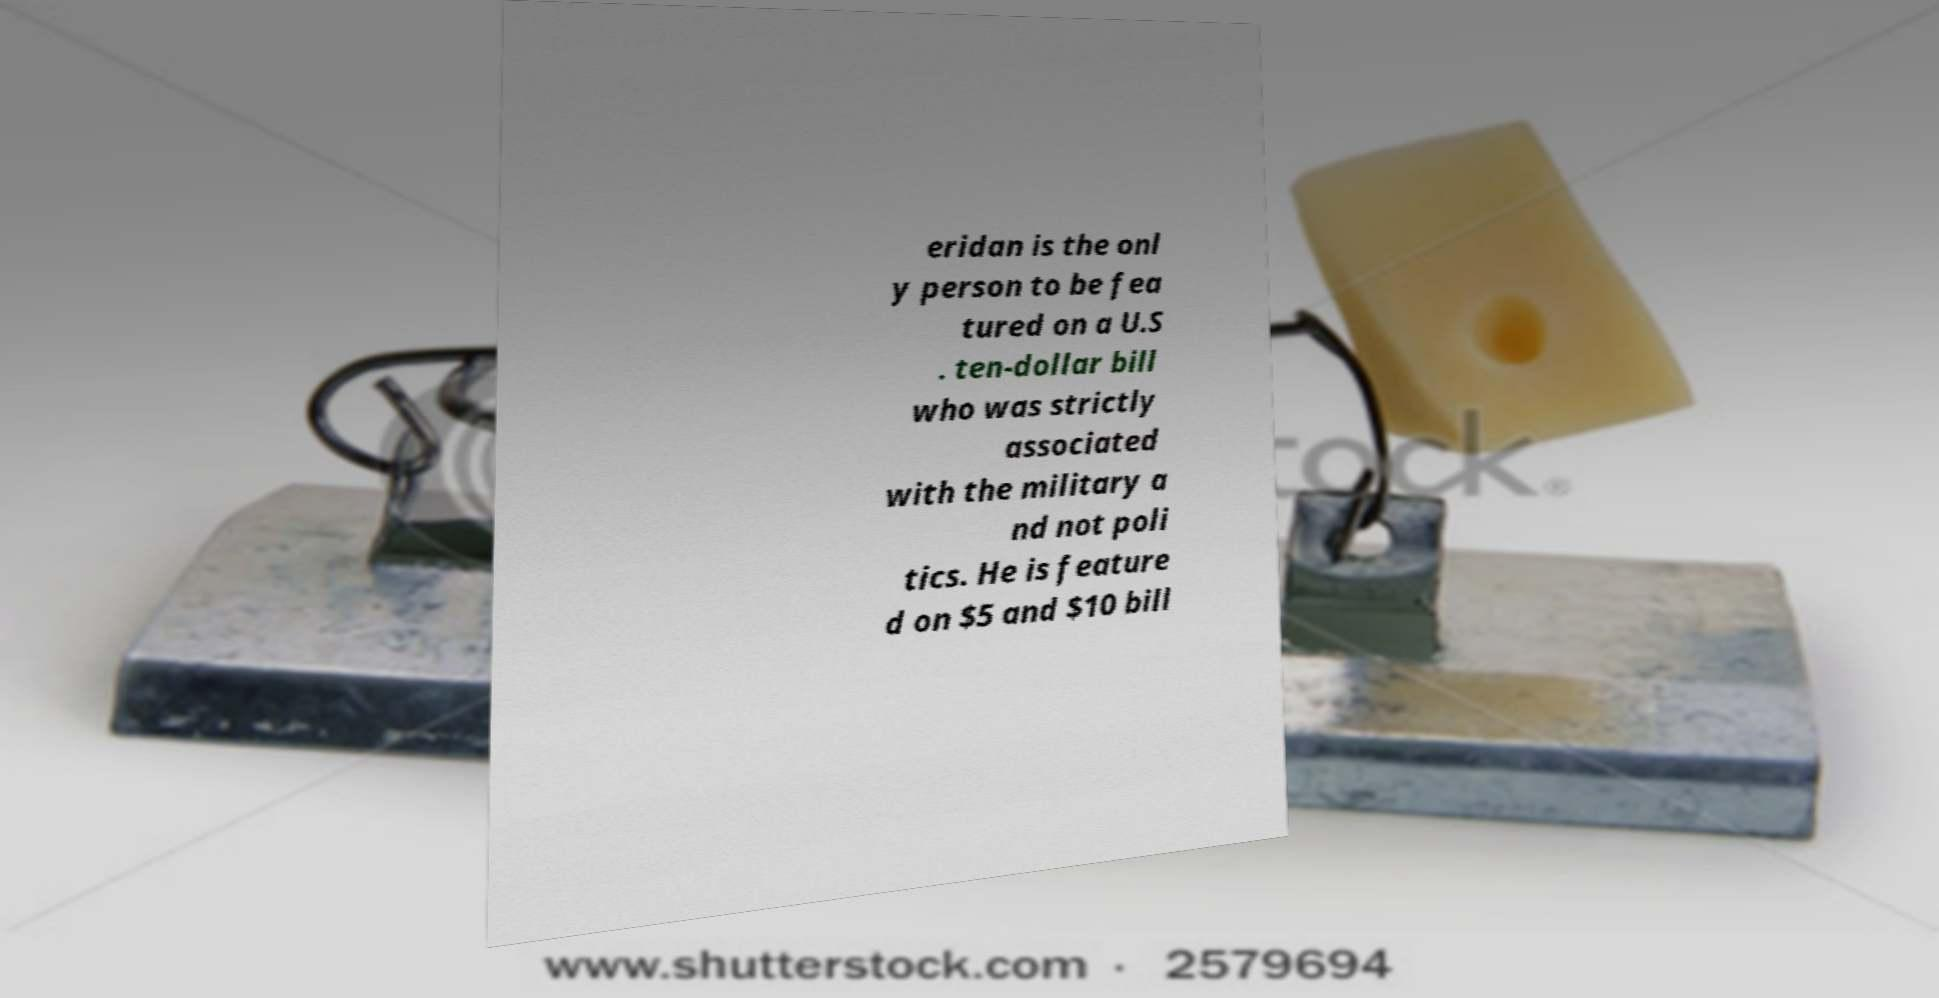Please identify and transcribe the text found in this image. eridan is the onl y person to be fea tured on a U.S . ten-dollar bill who was strictly associated with the military a nd not poli tics. He is feature d on $5 and $10 bill 